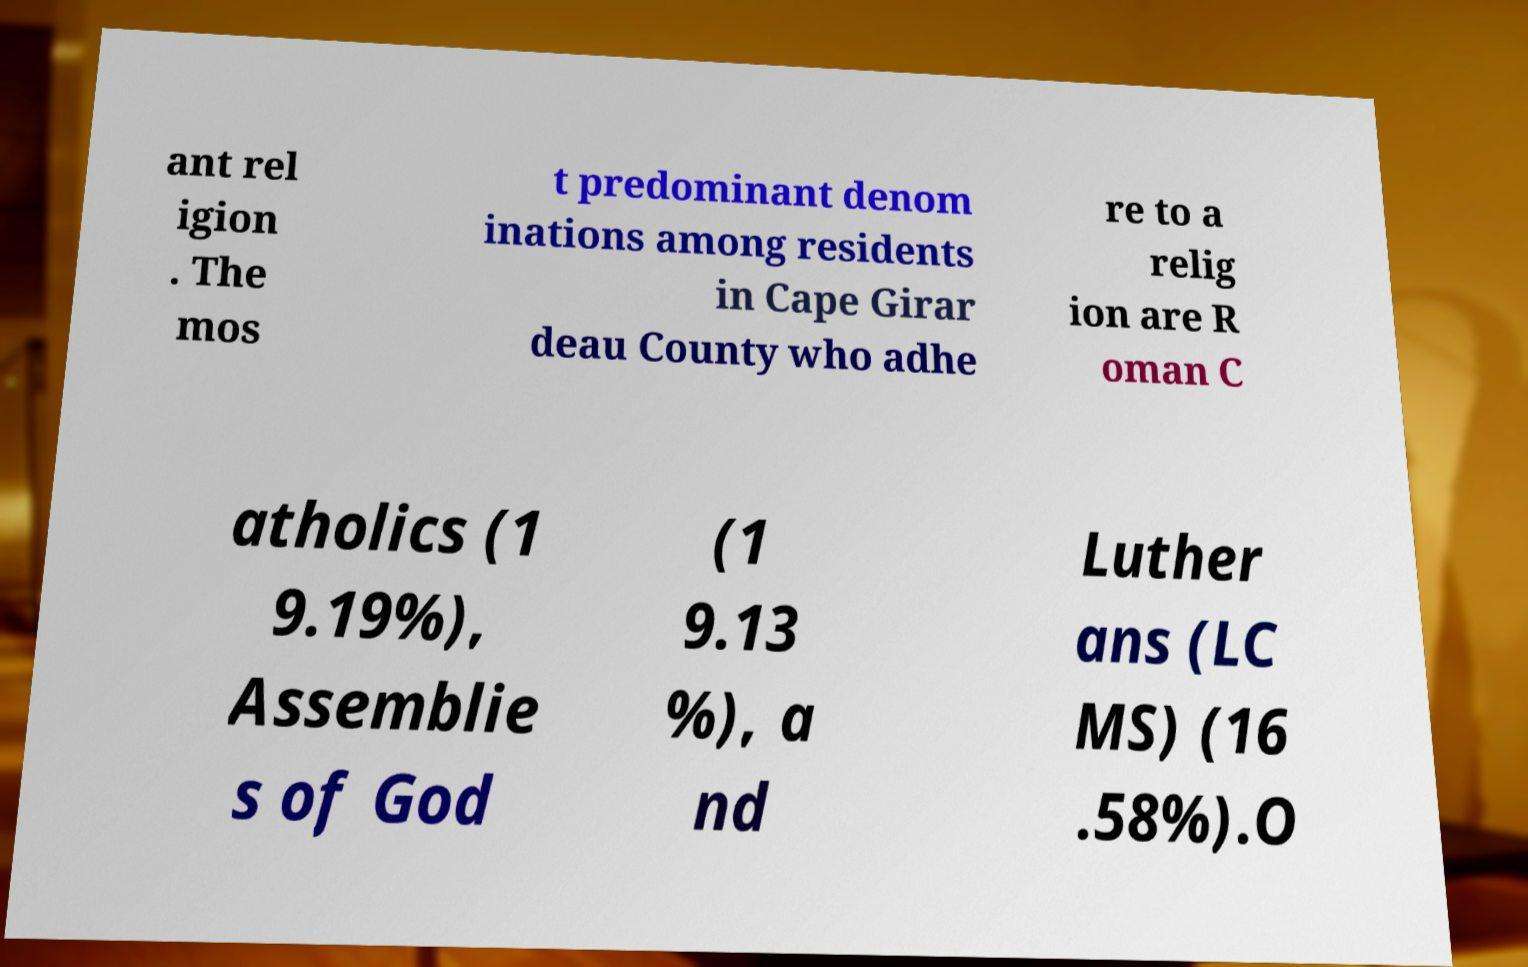Could you assist in decoding the text presented in this image and type it out clearly? ant rel igion . The mos t predominant denom inations among residents in Cape Girar deau County who adhe re to a relig ion are R oman C atholics (1 9.19%), Assemblie s of God (1 9.13 %), a nd Luther ans (LC MS) (16 .58%).O 